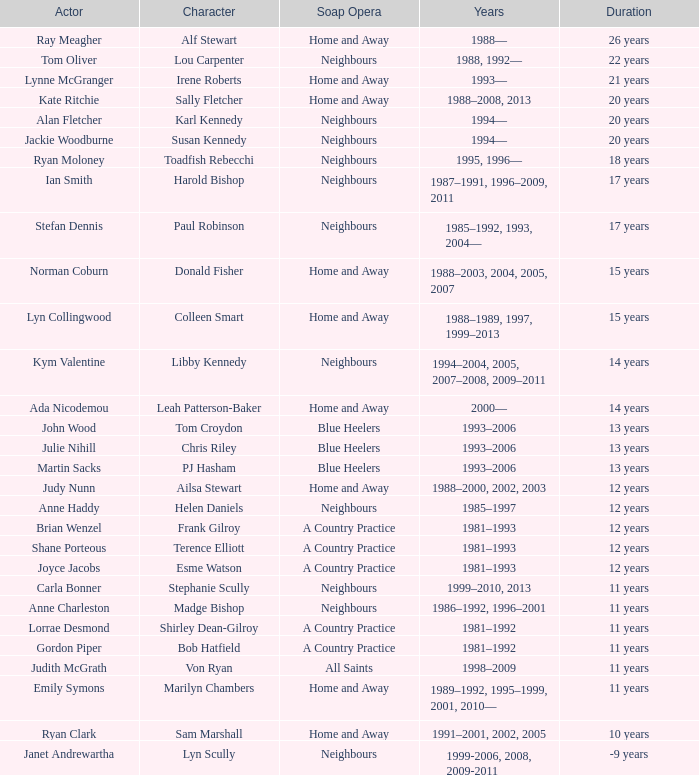What character was portrayed by the same actor for 12 years on Neighbours? Helen Daniels. 